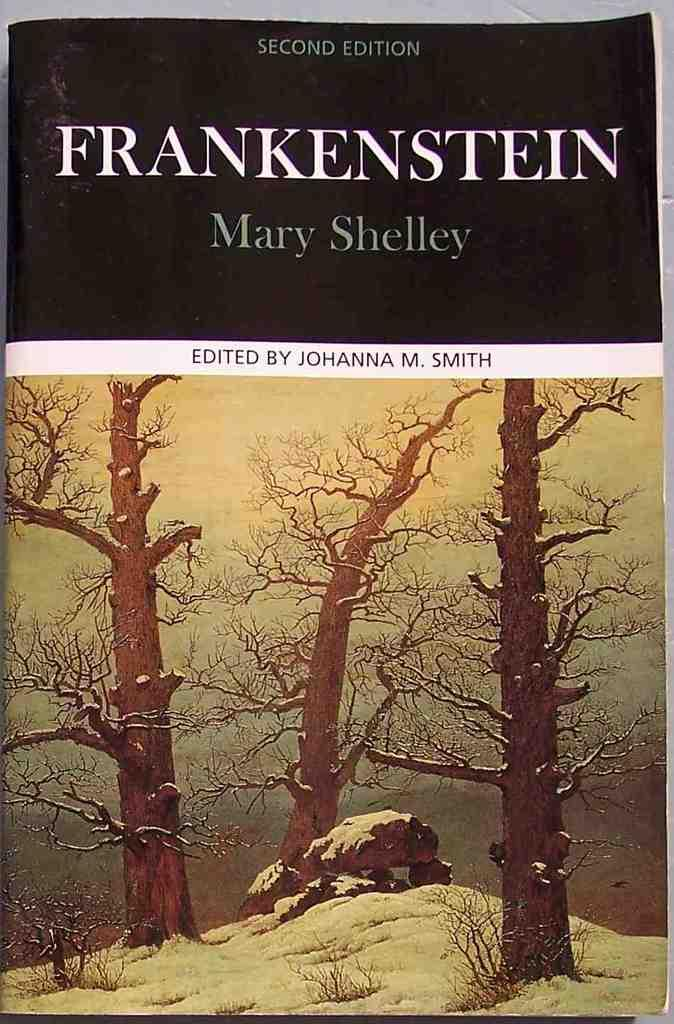<image>
Relay a brief, clear account of the picture shown. A book  bu Mary Shelley called Frankenstein. 